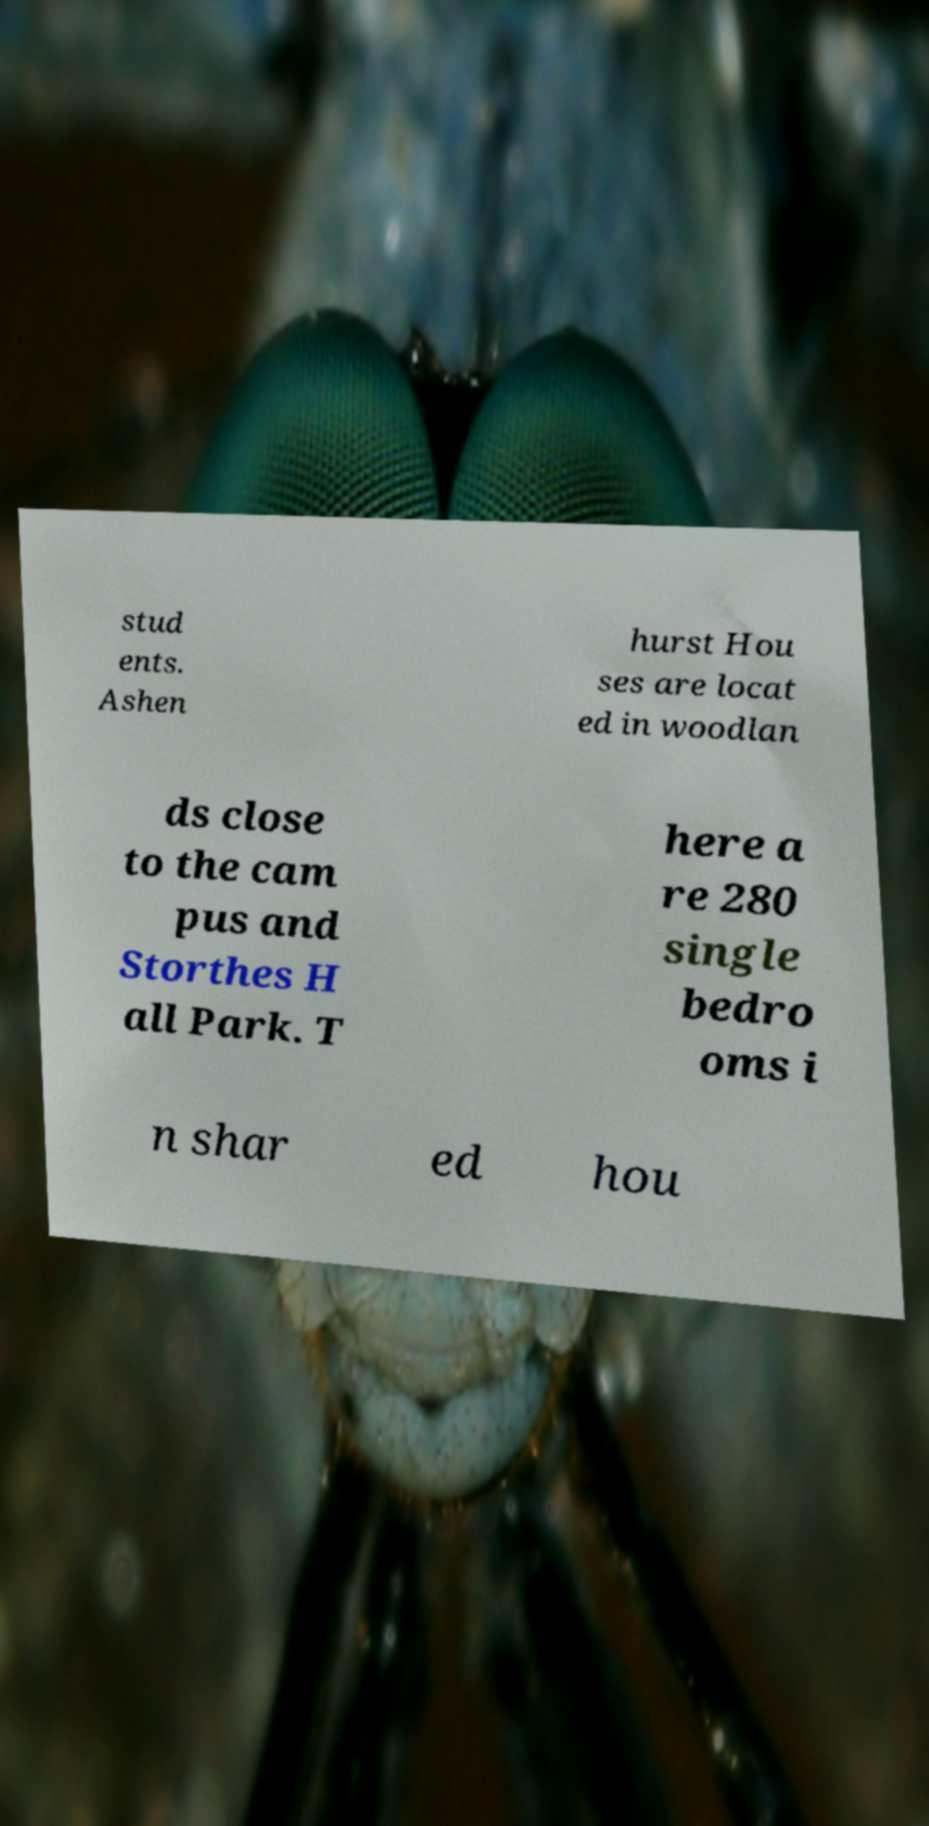What messages or text are displayed in this image? I need them in a readable, typed format. stud ents. Ashen hurst Hou ses are locat ed in woodlan ds close to the cam pus and Storthes H all Park. T here a re 280 single bedro oms i n shar ed hou 